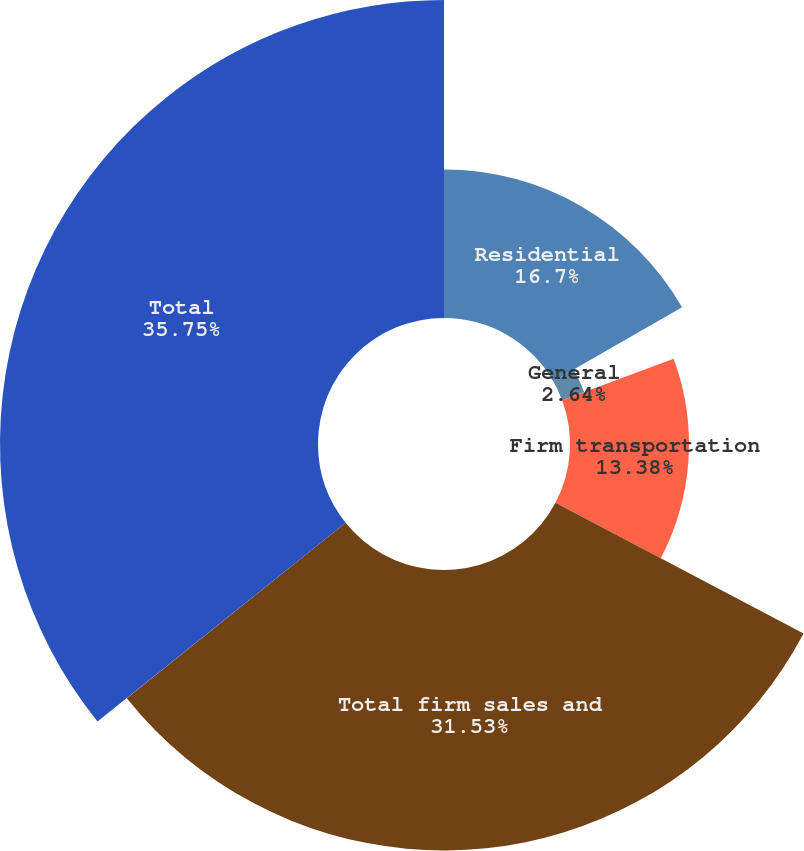Convert chart to OTSL. <chart><loc_0><loc_0><loc_500><loc_500><pie_chart><fcel>Residential<fcel>General<fcel>Firm transportation<fcel>Total firm sales and<fcel>Total<nl><fcel>16.7%<fcel>2.64%<fcel>13.38%<fcel>31.53%<fcel>35.75%<nl></chart> 